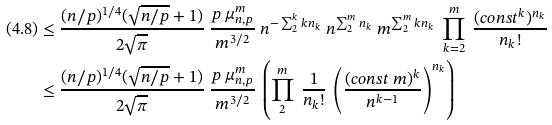<formula> <loc_0><loc_0><loc_500><loc_500>( 4 . 8 ) & \leq \frac { ( n / p ) ^ { 1 / 4 } ( \sqrt { n / p } + 1 ) } { 2 \sqrt { \pi } } \ \frac { p \ \mu _ { n , p } ^ { m } } { m ^ { 3 / 2 } } \ n ^ { - \sum _ { 2 } ^ { k } k n _ { k } } \ n ^ { \sum _ { 2 } ^ { m } n _ { k } } \ m ^ { \sum _ { 2 } ^ { m } k n _ { k } } \ \prod _ { k = 2 } ^ { m } \ \frac { ( c o n s t ^ { k } ) ^ { n _ { k } } } { n _ { k } ! } \\ & \leq \frac { ( n / p ) ^ { 1 / 4 } ( \sqrt { n / p } + 1 ) } { 2 \sqrt { \pi } } \ \frac { p \ \mu _ { n , p } ^ { m } } { m ^ { 3 / 2 } } \ \left ( \prod _ { 2 } ^ { m } \ \frac { 1 } { n _ { k } ! } \ \left ( \frac { ( c o n s t \ m ) ^ { k } } { n ^ { k - 1 } } \right ) ^ { n _ { k } } \right )</formula> 